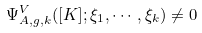<formula> <loc_0><loc_0><loc_500><loc_500>\Psi ^ { V } _ { A , g , k } ( [ K ] ; \xi _ { 1 } , \cdots , \xi _ { k } ) \ne 0</formula> 